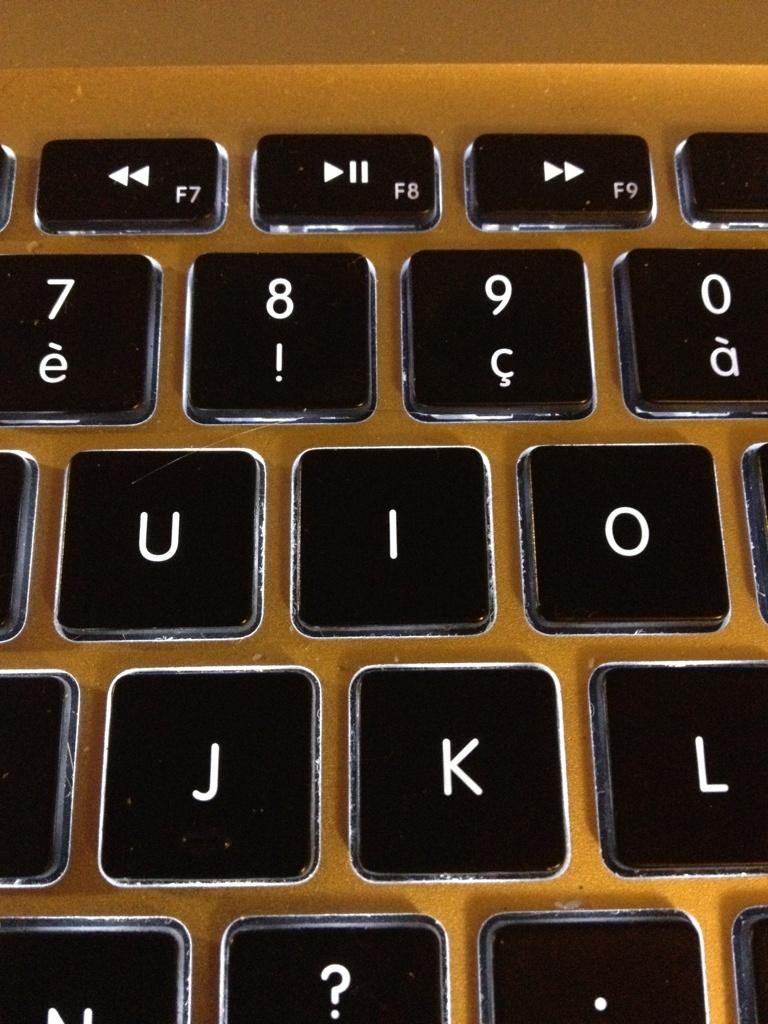<image>
Present a compact description of the photo's key features. A close up of the U, I, O, J, and K keys on a keyboard. 